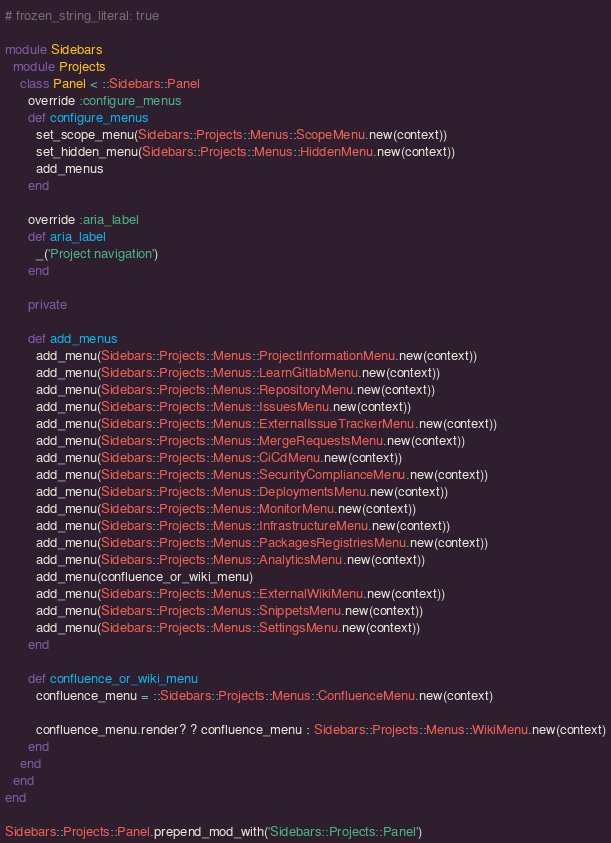<code> <loc_0><loc_0><loc_500><loc_500><_Ruby_># frozen_string_literal: true

module Sidebars
  module Projects
    class Panel < ::Sidebars::Panel
      override :configure_menus
      def configure_menus
        set_scope_menu(Sidebars::Projects::Menus::ScopeMenu.new(context))
        set_hidden_menu(Sidebars::Projects::Menus::HiddenMenu.new(context))
        add_menus
      end

      override :aria_label
      def aria_label
        _('Project navigation')
      end

      private

      def add_menus
        add_menu(Sidebars::Projects::Menus::ProjectInformationMenu.new(context))
        add_menu(Sidebars::Projects::Menus::LearnGitlabMenu.new(context))
        add_menu(Sidebars::Projects::Menus::RepositoryMenu.new(context))
        add_menu(Sidebars::Projects::Menus::IssuesMenu.new(context))
        add_menu(Sidebars::Projects::Menus::ExternalIssueTrackerMenu.new(context))
        add_menu(Sidebars::Projects::Menus::MergeRequestsMenu.new(context))
        add_menu(Sidebars::Projects::Menus::CiCdMenu.new(context))
        add_menu(Sidebars::Projects::Menus::SecurityComplianceMenu.new(context))
        add_menu(Sidebars::Projects::Menus::DeploymentsMenu.new(context))
        add_menu(Sidebars::Projects::Menus::MonitorMenu.new(context))
        add_menu(Sidebars::Projects::Menus::InfrastructureMenu.new(context))
        add_menu(Sidebars::Projects::Menus::PackagesRegistriesMenu.new(context))
        add_menu(Sidebars::Projects::Menus::AnalyticsMenu.new(context))
        add_menu(confluence_or_wiki_menu)
        add_menu(Sidebars::Projects::Menus::ExternalWikiMenu.new(context))
        add_menu(Sidebars::Projects::Menus::SnippetsMenu.new(context))
        add_menu(Sidebars::Projects::Menus::SettingsMenu.new(context))
      end

      def confluence_or_wiki_menu
        confluence_menu = ::Sidebars::Projects::Menus::ConfluenceMenu.new(context)

        confluence_menu.render? ? confluence_menu : Sidebars::Projects::Menus::WikiMenu.new(context)
      end
    end
  end
end

Sidebars::Projects::Panel.prepend_mod_with('Sidebars::Projects::Panel')
</code> 